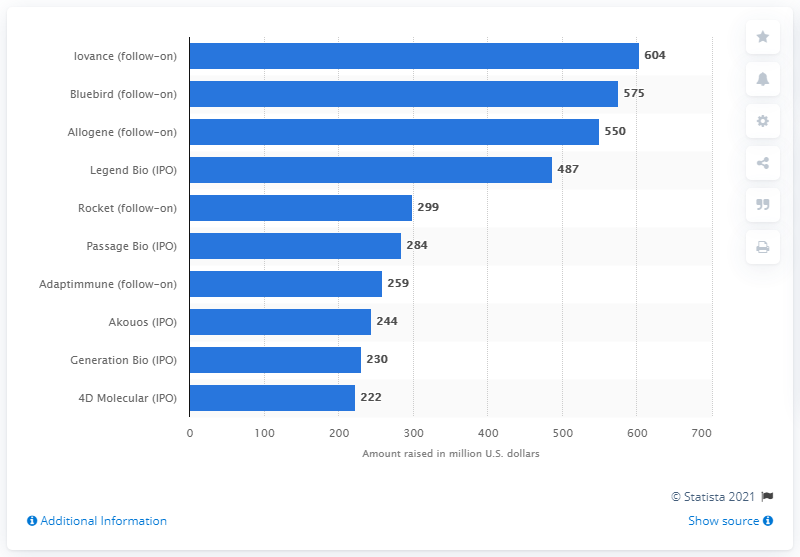Point out several critical features in this image. Iovance raised $604 million in U.S. dollars. 